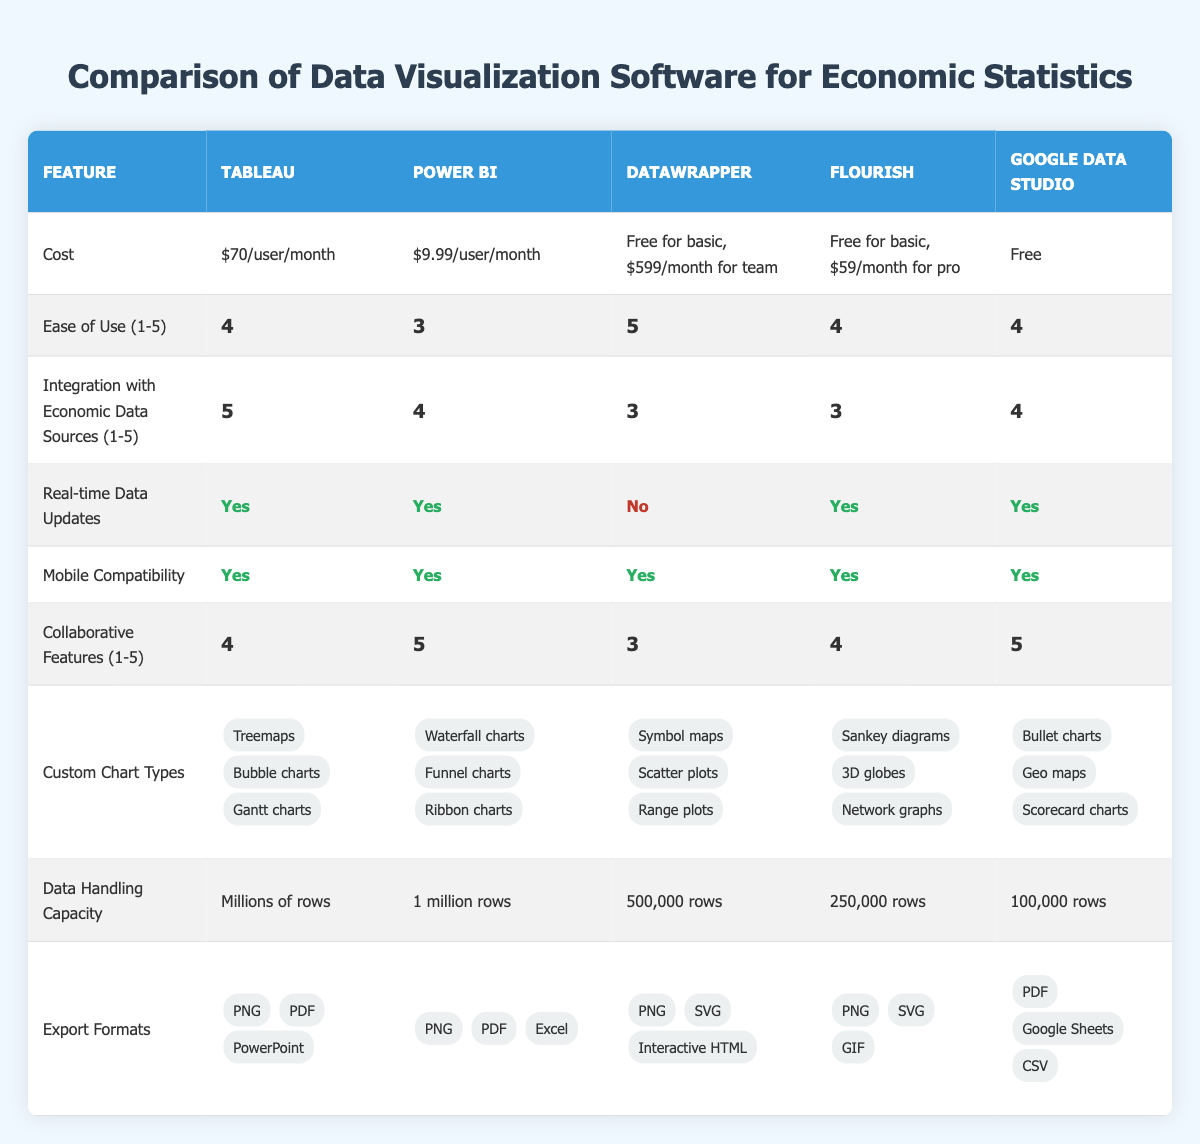What is the cost of Tableau? The cost of Tableau is stated directly in the table under the "Cost" row for Tableau.
Answer: $70/user/month Which software has the highest ease of use rating? The ease of use ratings are given in the table; Datawrapper has a rating of 5, which is the highest.
Answer: Datawrapper How many export formats does Power BI support? The table lists three export formats for Power BI: PNG, PDF, and Excel.
Answer: 3 Is Flourish capable of real-time data updates? The table indicates that Flourish, under the "Real-time Data Updates" row, has a "Yes" value, meaning it supports real-time updates.
Answer: Yes What is the difference in data handling capacity between Tableau and Google Data Studio? Tableau can handle millions of rows, while Google Data Studio can handle 100,000 rows. The difference is that Tableau's capacity is significantly higher, but without an exact numerical difference, we can conclude it's millions vs. 100,000.
Answer: Millions vs. 100,000 What is the average ease of use rating for the software listed? The ratings are 4, 3, 5, 4, and 4. To find the average, we sum these values (4 + 3 + 5 + 4 + 4) = 20, and divide by the number of software (5). Thus, the average is 20/5 = 4.
Answer: 4 Which software offers the most options for custom chart types? The table lists custom chart types for each software; Tableau offers three types, Power BI offers three, Datawrapper offers three, Flourish offers three, and Google Data Studio offers three. Therefore, all software have the same number of custom chart types.
Answer: All have the same number Does Google Data Studio have any collaborative features? The table shows that Google Data Studio has a rating of 5 for collaborative features, indicating strong collaboration capabilities.
Answer: Yes Which software is the least expensive option for a team setup? Datawrapper allows a free version for basic use and charges $599/month for team access, which would be more expensive than Flourish's pro version at $59/month. Therefore, Flourish's pro version is the least expensive for a team setup.
Answer: Flourish 